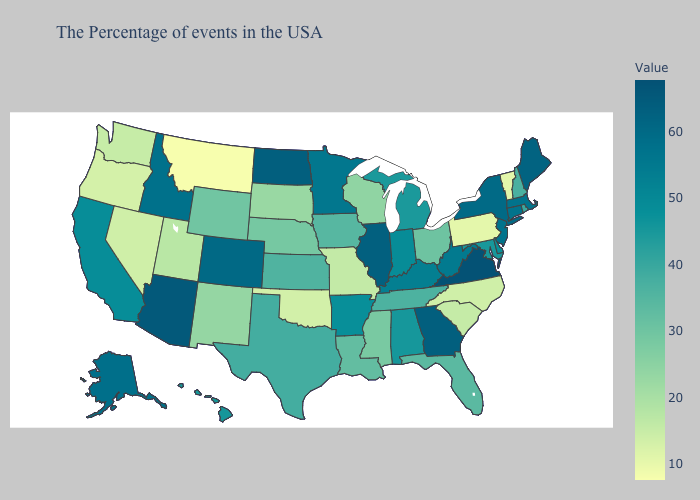Does Nevada have a higher value than Montana?
Quick response, please. Yes. Does Maine have the highest value in the Northeast?
Short answer required. Yes. Does Nevada have a lower value than Montana?
Answer briefly. No. Among the states that border Georgia , which have the highest value?
Short answer required. Alabama. Which states hav the highest value in the Northeast?
Concise answer only. Maine. Which states have the lowest value in the Northeast?
Short answer required. Pennsylvania. 